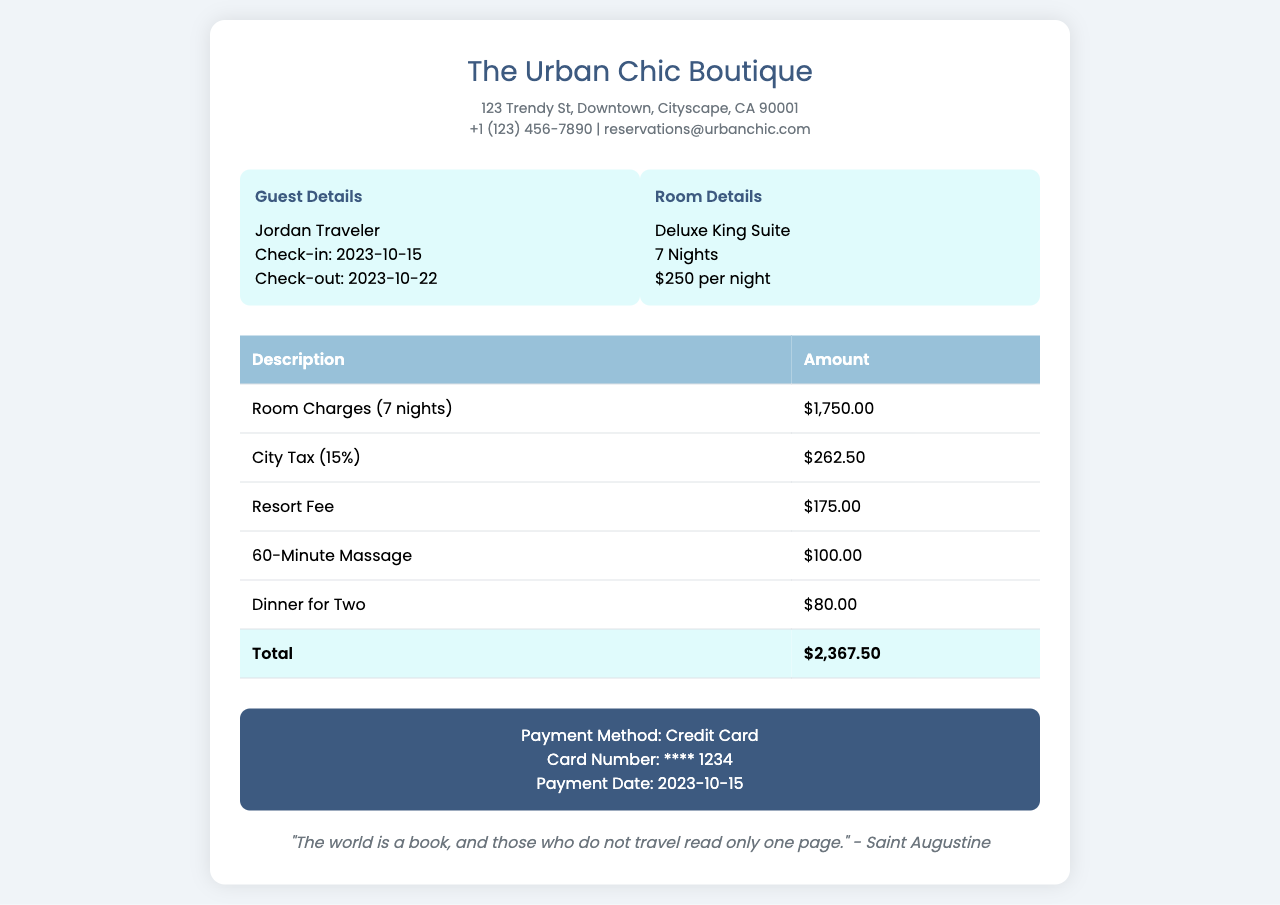What is the name of the hotel? The hotel name is clearly stated at the top of the invoice.
Answer: The Urban Chic Boutique What is the check-in date? The check-in date is provided in the guest information section.
Answer: 2023-10-15 What is the daily room rate for the suite? The room details specify the per night rate.
Answer: $250 per night How much is the city tax? The city tax amount is displayed in the charges table.
Answer: $262.50 What extra service was included for a couple? An expense for a couple is listed which indicates a special service.
Answer: Dinner for Two How many nights did the guest stay? The duration of the stay is noted in the room details section.
Answer: 7 Nights What is the payment method used? The payment method is mentioned at the bottom of the invoice.
Answer: Credit Card What is the total amount due? The total amount is summarized in the total row of the charges table.
Answer: $2,367.50 What was the date of payment? The payment date is specified in the payment information section.
Answer: 2023-10-15 